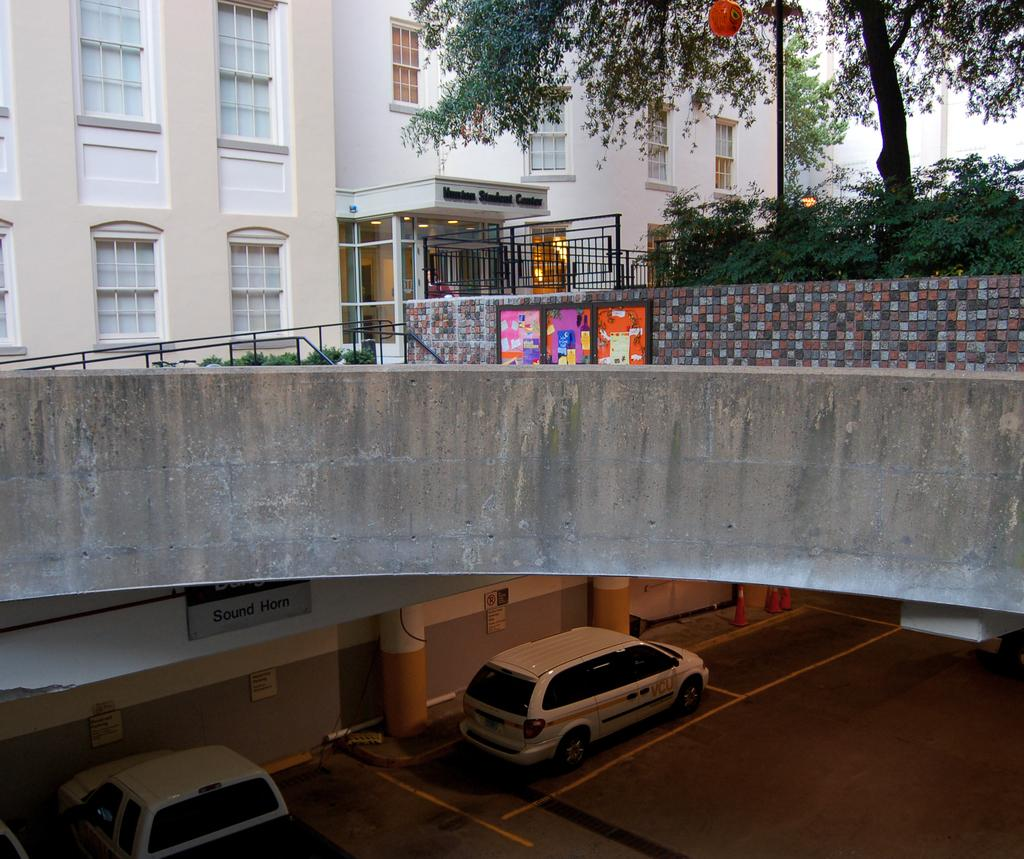What type of structure can be seen in the image? There is a building in the image. What other natural elements are present in the image? There are plants, trees, and a road in the image. What man-made feature connects two areas in the image? There is a bridge in the image. What vehicles can be seen on the road in the image? There are vehicles on the road in the image. What additional object can be seen in the image? There is a board in the image. What architectural elements support the building in the image? There are pillars in the image. Where is the crown placed on the board in the image? There is no crown present in the image. How do the trees join together to form a canopy in the image? The trees do not join together to form a canopy in the image; they are separate trees. 